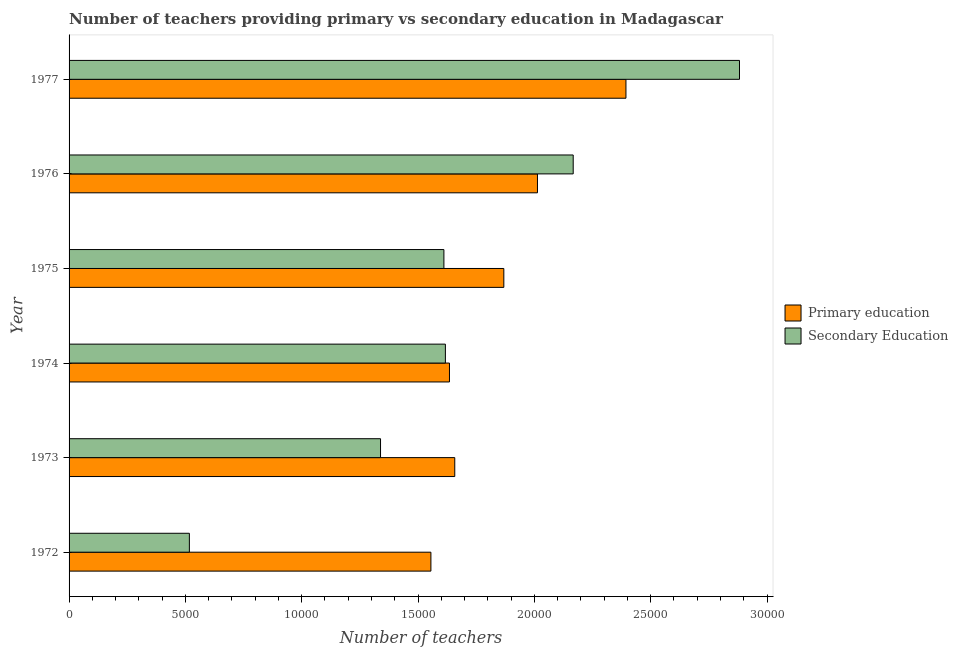How many different coloured bars are there?
Your answer should be very brief. 2. How many groups of bars are there?
Your answer should be very brief. 6. How many bars are there on the 6th tick from the top?
Keep it short and to the point. 2. What is the number of secondary teachers in 1973?
Provide a short and direct response. 1.34e+04. Across all years, what is the maximum number of primary teachers?
Offer a terse response. 2.39e+04. Across all years, what is the minimum number of primary teachers?
Your response must be concise. 1.56e+04. In which year was the number of primary teachers minimum?
Your answer should be very brief. 1972. What is the total number of primary teachers in the graph?
Your answer should be very brief. 1.11e+05. What is the difference between the number of secondary teachers in 1974 and that in 1976?
Give a very brief answer. -5494. What is the difference between the number of secondary teachers in 1973 and the number of primary teachers in 1976?
Keep it short and to the point. -6746. What is the average number of primary teachers per year?
Give a very brief answer. 1.85e+04. In the year 1972, what is the difference between the number of secondary teachers and number of primary teachers?
Give a very brief answer. -1.04e+04. What is the ratio of the number of primary teachers in 1972 to that in 1976?
Offer a very short reply. 0.77. Is the difference between the number of primary teachers in 1973 and 1977 greater than the difference between the number of secondary teachers in 1973 and 1977?
Your answer should be compact. Yes. What is the difference between the highest and the second highest number of secondary teachers?
Your answer should be very brief. 7148. What is the difference between the highest and the lowest number of secondary teachers?
Your answer should be very brief. 2.36e+04. What does the 1st bar from the top in 1975 represents?
Give a very brief answer. Secondary Education. What does the 1st bar from the bottom in 1973 represents?
Your response must be concise. Primary education. How many years are there in the graph?
Give a very brief answer. 6. What is the difference between two consecutive major ticks on the X-axis?
Provide a succinct answer. 5000. Are the values on the major ticks of X-axis written in scientific E-notation?
Give a very brief answer. No. Does the graph contain grids?
Your answer should be compact. No. Where does the legend appear in the graph?
Make the answer very short. Center right. How many legend labels are there?
Offer a very short reply. 2. How are the legend labels stacked?
Provide a short and direct response. Vertical. What is the title of the graph?
Give a very brief answer. Number of teachers providing primary vs secondary education in Madagascar. What is the label or title of the X-axis?
Your answer should be very brief. Number of teachers. What is the Number of teachers of Primary education in 1972?
Make the answer very short. 1.56e+04. What is the Number of teachers of Secondary Education in 1972?
Ensure brevity in your answer.  5171. What is the Number of teachers of Primary education in 1973?
Your response must be concise. 1.66e+04. What is the Number of teachers in Secondary Education in 1973?
Offer a very short reply. 1.34e+04. What is the Number of teachers in Primary education in 1974?
Offer a very short reply. 1.64e+04. What is the Number of teachers of Secondary Education in 1974?
Offer a terse response. 1.62e+04. What is the Number of teachers in Primary education in 1975?
Ensure brevity in your answer.  1.87e+04. What is the Number of teachers in Secondary Education in 1975?
Keep it short and to the point. 1.61e+04. What is the Number of teachers of Primary education in 1976?
Offer a terse response. 2.01e+04. What is the Number of teachers in Secondary Education in 1976?
Give a very brief answer. 2.17e+04. What is the Number of teachers of Primary education in 1977?
Make the answer very short. 2.39e+04. What is the Number of teachers in Secondary Education in 1977?
Make the answer very short. 2.88e+04. Across all years, what is the maximum Number of teachers in Primary education?
Offer a terse response. 2.39e+04. Across all years, what is the maximum Number of teachers of Secondary Education?
Provide a short and direct response. 2.88e+04. Across all years, what is the minimum Number of teachers in Primary education?
Keep it short and to the point. 1.56e+04. Across all years, what is the minimum Number of teachers in Secondary Education?
Offer a very short reply. 5171. What is the total Number of teachers of Primary education in the graph?
Provide a succinct answer. 1.11e+05. What is the total Number of teachers of Secondary Education in the graph?
Keep it short and to the point. 1.01e+05. What is the difference between the Number of teachers in Primary education in 1972 and that in 1973?
Keep it short and to the point. -1026. What is the difference between the Number of teachers of Secondary Education in 1972 and that in 1973?
Provide a short and direct response. -8217. What is the difference between the Number of teachers of Primary education in 1972 and that in 1974?
Provide a short and direct response. -798. What is the difference between the Number of teachers of Secondary Education in 1972 and that in 1974?
Your response must be concise. -1.10e+04. What is the difference between the Number of teachers of Primary education in 1972 and that in 1975?
Make the answer very short. -3135. What is the difference between the Number of teachers of Secondary Education in 1972 and that in 1975?
Give a very brief answer. -1.09e+04. What is the difference between the Number of teachers in Primary education in 1972 and that in 1976?
Keep it short and to the point. -4581. What is the difference between the Number of teachers in Secondary Education in 1972 and that in 1976?
Keep it short and to the point. -1.65e+04. What is the difference between the Number of teachers of Primary education in 1972 and that in 1977?
Your answer should be compact. -8384. What is the difference between the Number of teachers in Secondary Education in 1972 and that in 1977?
Your answer should be compact. -2.36e+04. What is the difference between the Number of teachers in Primary education in 1973 and that in 1974?
Make the answer very short. 228. What is the difference between the Number of teachers of Secondary Education in 1973 and that in 1974?
Keep it short and to the point. -2788. What is the difference between the Number of teachers in Primary education in 1973 and that in 1975?
Make the answer very short. -2109. What is the difference between the Number of teachers in Secondary Education in 1973 and that in 1975?
Your answer should be very brief. -2724. What is the difference between the Number of teachers of Primary education in 1973 and that in 1976?
Offer a very short reply. -3555. What is the difference between the Number of teachers of Secondary Education in 1973 and that in 1976?
Provide a short and direct response. -8282. What is the difference between the Number of teachers of Primary education in 1973 and that in 1977?
Ensure brevity in your answer.  -7358. What is the difference between the Number of teachers of Secondary Education in 1973 and that in 1977?
Offer a very short reply. -1.54e+04. What is the difference between the Number of teachers in Primary education in 1974 and that in 1975?
Provide a succinct answer. -2337. What is the difference between the Number of teachers of Secondary Education in 1974 and that in 1975?
Offer a very short reply. 64. What is the difference between the Number of teachers in Primary education in 1974 and that in 1976?
Keep it short and to the point. -3783. What is the difference between the Number of teachers in Secondary Education in 1974 and that in 1976?
Provide a short and direct response. -5494. What is the difference between the Number of teachers in Primary education in 1974 and that in 1977?
Your answer should be very brief. -7586. What is the difference between the Number of teachers of Secondary Education in 1974 and that in 1977?
Ensure brevity in your answer.  -1.26e+04. What is the difference between the Number of teachers in Primary education in 1975 and that in 1976?
Your answer should be compact. -1446. What is the difference between the Number of teachers in Secondary Education in 1975 and that in 1976?
Your response must be concise. -5558. What is the difference between the Number of teachers of Primary education in 1975 and that in 1977?
Keep it short and to the point. -5249. What is the difference between the Number of teachers of Secondary Education in 1975 and that in 1977?
Make the answer very short. -1.27e+04. What is the difference between the Number of teachers of Primary education in 1976 and that in 1977?
Provide a succinct answer. -3803. What is the difference between the Number of teachers in Secondary Education in 1976 and that in 1977?
Make the answer very short. -7148. What is the difference between the Number of teachers of Primary education in 1972 and the Number of teachers of Secondary Education in 1973?
Give a very brief answer. 2165. What is the difference between the Number of teachers of Primary education in 1972 and the Number of teachers of Secondary Education in 1974?
Offer a very short reply. -623. What is the difference between the Number of teachers of Primary education in 1972 and the Number of teachers of Secondary Education in 1975?
Offer a very short reply. -559. What is the difference between the Number of teachers of Primary education in 1972 and the Number of teachers of Secondary Education in 1976?
Your answer should be compact. -6117. What is the difference between the Number of teachers of Primary education in 1972 and the Number of teachers of Secondary Education in 1977?
Ensure brevity in your answer.  -1.33e+04. What is the difference between the Number of teachers in Primary education in 1973 and the Number of teachers in Secondary Education in 1974?
Provide a succinct answer. 403. What is the difference between the Number of teachers of Primary education in 1973 and the Number of teachers of Secondary Education in 1975?
Your answer should be very brief. 467. What is the difference between the Number of teachers of Primary education in 1973 and the Number of teachers of Secondary Education in 1976?
Ensure brevity in your answer.  -5091. What is the difference between the Number of teachers in Primary education in 1973 and the Number of teachers in Secondary Education in 1977?
Keep it short and to the point. -1.22e+04. What is the difference between the Number of teachers of Primary education in 1974 and the Number of teachers of Secondary Education in 1975?
Your response must be concise. 239. What is the difference between the Number of teachers of Primary education in 1974 and the Number of teachers of Secondary Education in 1976?
Make the answer very short. -5319. What is the difference between the Number of teachers of Primary education in 1974 and the Number of teachers of Secondary Education in 1977?
Offer a very short reply. -1.25e+04. What is the difference between the Number of teachers of Primary education in 1975 and the Number of teachers of Secondary Education in 1976?
Your answer should be very brief. -2982. What is the difference between the Number of teachers in Primary education in 1975 and the Number of teachers in Secondary Education in 1977?
Ensure brevity in your answer.  -1.01e+04. What is the difference between the Number of teachers of Primary education in 1976 and the Number of teachers of Secondary Education in 1977?
Provide a short and direct response. -8684. What is the average Number of teachers in Primary education per year?
Your answer should be very brief. 1.85e+04. What is the average Number of teachers in Secondary Education per year?
Provide a short and direct response. 1.69e+04. In the year 1972, what is the difference between the Number of teachers in Primary education and Number of teachers in Secondary Education?
Ensure brevity in your answer.  1.04e+04. In the year 1973, what is the difference between the Number of teachers in Primary education and Number of teachers in Secondary Education?
Give a very brief answer. 3191. In the year 1974, what is the difference between the Number of teachers of Primary education and Number of teachers of Secondary Education?
Provide a succinct answer. 175. In the year 1975, what is the difference between the Number of teachers of Primary education and Number of teachers of Secondary Education?
Your response must be concise. 2576. In the year 1976, what is the difference between the Number of teachers in Primary education and Number of teachers in Secondary Education?
Your answer should be very brief. -1536. In the year 1977, what is the difference between the Number of teachers in Primary education and Number of teachers in Secondary Education?
Give a very brief answer. -4881. What is the ratio of the Number of teachers in Primary education in 1972 to that in 1973?
Give a very brief answer. 0.94. What is the ratio of the Number of teachers in Secondary Education in 1972 to that in 1973?
Provide a short and direct response. 0.39. What is the ratio of the Number of teachers of Primary education in 1972 to that in 1974?
Your answer should be very brief. 0.95. What is the ratio of the Number of teachers of Secondary Education in 1972 to that in 1974?
Ensure brevity in your answer.  0.32. What is the ratio of the Number of teachers of Primary education in 1972 to that in 1975?
Provide a short and direct response. 0.83. What is the ratio of the Number of teachers in Secondary Education in 1972 to that in 1975?
Offer a terse response. 0.32. What is the ratio of the Number of teachers of Primary education in 1972 to that in 1976?
Provide a short and direct response. 0.77. What is the ratio of the Number of teachers in Secondary Education in 1972 to that in 1976?
Make the answer very short. 0.24. What is the ratio of the Number of teachers of Primary education in 1972 to that in 1977?
Offer a terse response. 0.65. What is the ratio of the Number of teachers in Secondary Education in 1972 to that in 1977?
Your answer should be very brief. 0.18. What is the ratio of the Number of teachers of Primary education in 1973 to that in 1974?
Offer a terse response. 1.01. What is the ratio of the Number of teachers in Secondary Education in 1973 to that in 1974?
Your answer should be very brief. 0.83. What is the ratio of the Number of teachers of Primary education in 1973 to that in 1975?
Give a very brief answer. 0.89. What is the ratio of the Number of teachers in Secondary Education in 1973 to that in 1975?
Give a very brief answer. 0.83. What is the ratio of the Number of teachers of Primary education in 1973 to that in 1976?
Offer a terse response. 0.82. What is the ratio of the Number of teachers of Secondary Education in 1973 to that in 1976?
Offer a very short reply. 0.62. What is the ratio of the Number of teachers of Primary education in 1973 to that in 1977?
Provide a short and direct response. 0.69. What is the ratio of the Number of teachers in Secondary Education in 1973 to that in 1977?
Your answer should be compact. 0.46. What is the ratio of the Number of teachers in Primary education in 1974 to that in 1975?
Provide a succinct answer. 0.87. What is the ratio of the Number of teachers in Primary education in 1974 to that in 1976?
Make the answer very short. 0.81. What is the ratio of the Number of teachers in Secondary Education in 1974 to that in 1976?
Your response must be concise. 0.75. What is the ratio of the Number of teachers of Primary education in 1974 to that in 1977?
Ensure brevity in your answer.  0.68. What is the ratio of the Number of teachers of Secondary Education in 1974 to that in 1977?
Give a very brief answer. 0.56. What is the ratio of the Number of teachers of Primary education in 1975 to that in 1976?
Offer a terse response. 0.93. What is the ratio of the Number of teachers of Secondary Education in 1975 to that in 1976?
Make the answer very short. 0.74. What is the ratio of the Number of teachers in Primary education in 1975 to that in 1977?
Your response must be concise. 0.78. What is the ratio of the Number of teachers of Secondary Education in 1975 to that in 1977?
Offer a terse response. 0.56. What is the ratio of the Number of teachers in Primary education in 1976 to that in 1977?
Your answer should be very brief. 0.84. What is the ratio of the Number of teachers in Secondary Education in 1976 to that in 1977?
Your answer should be compact. 0.75. What is the difference between the highest and the second highest Number of teachers in Primary education?
Your response must be concise. 3803. What is the difference between the highest and the second highest Number of teachers in Secondary Education?
Offer a terse response. 7148. What is the difference between the highest and the lowest Number of teachers of Primary education?
Provide a short and direct response. 8384. What is the difference between the highest and the lowest Number of teachers in Secondary Education?
Offer a terse response. 2.36e+04. 